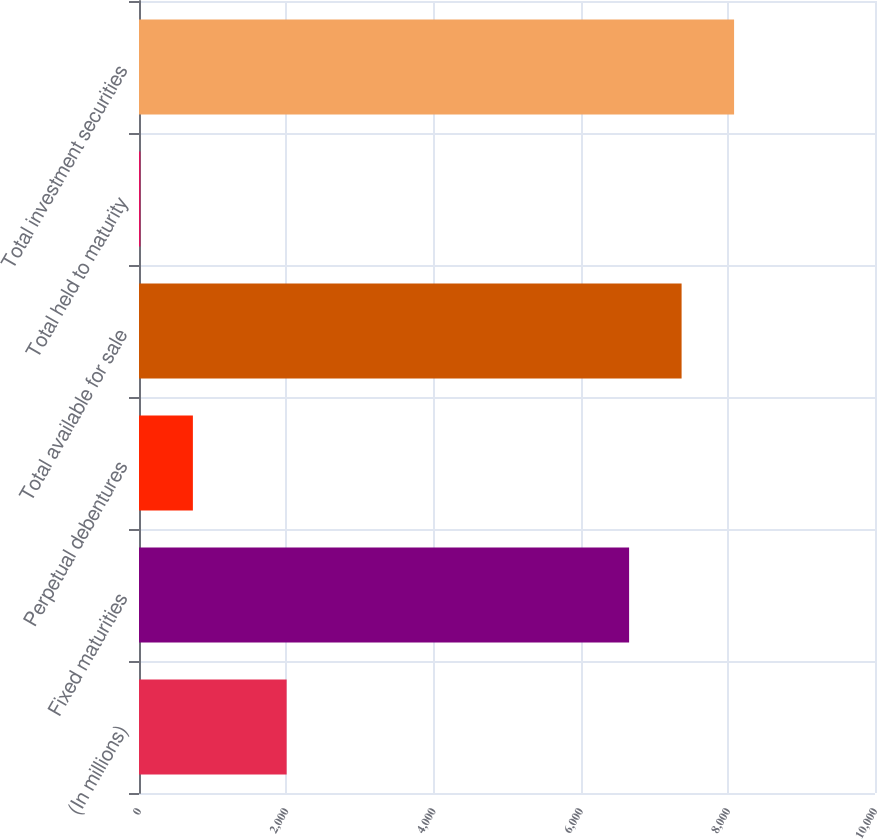<chart> <loc_0><loc_0><loc_500><loc_500><bar_chart><fcel>(In millions)<fcel>Fixed maturities<fcel>Perpetual debentures<fcel>Total available for sale<fcel>Total held to maturity<fcel>Total investment securities<nl><fcel>2006<fcel>6659<fcel>732.2<fcel>7372.2<fcel>19<fcel>8085.4<nl></chart> 